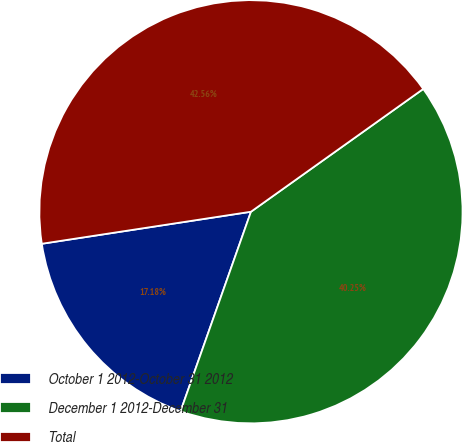Convert chart to OTSL. <chart><loc_0><loc_0><loc_500><loc_500><pie_chart><fcel>October 1 2012-October 31 2012<fcel>December 1 2012-December 31<fcel>Total<nl><fcel>17.18%<fcel>40.25%<fcel>42.56%<nl></chart> 